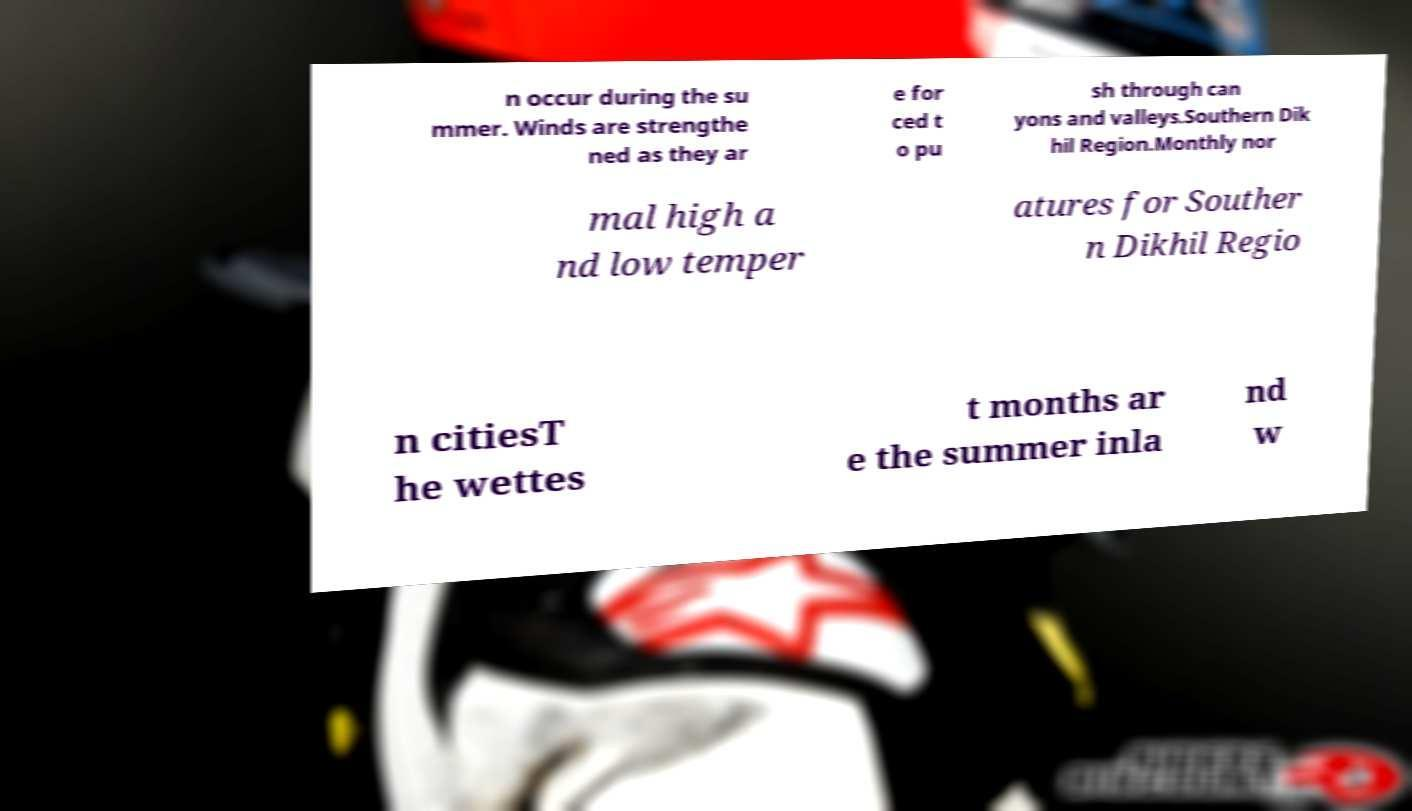Could you assist in decoding the text presented in this image and type it out clearly? n occur during the su mmer. Winds are strengthe ned as they ar e for ced t o pu sh through can yons and valleys.Southern Dik hil Region.Monthly nor mal high a nd low temper atures for Souther n Dikhil Regio n citiesT he wettes t months ar e the summer inla nd w 